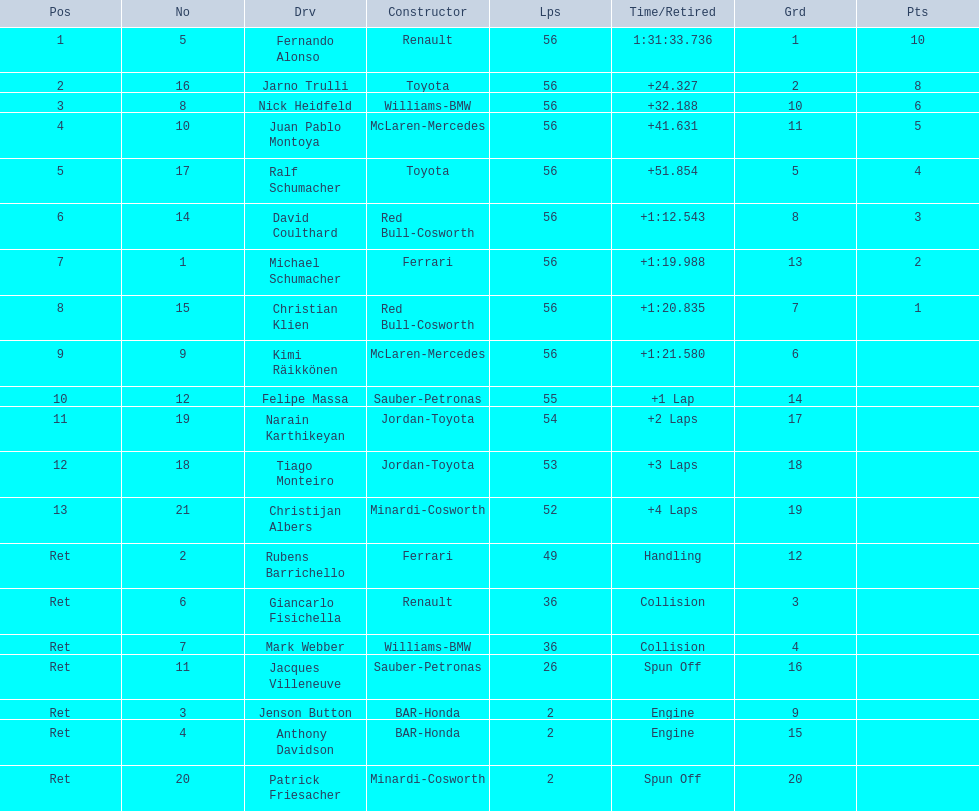How long did it take fernando alonso to finish the race? 1:31:33.736. 